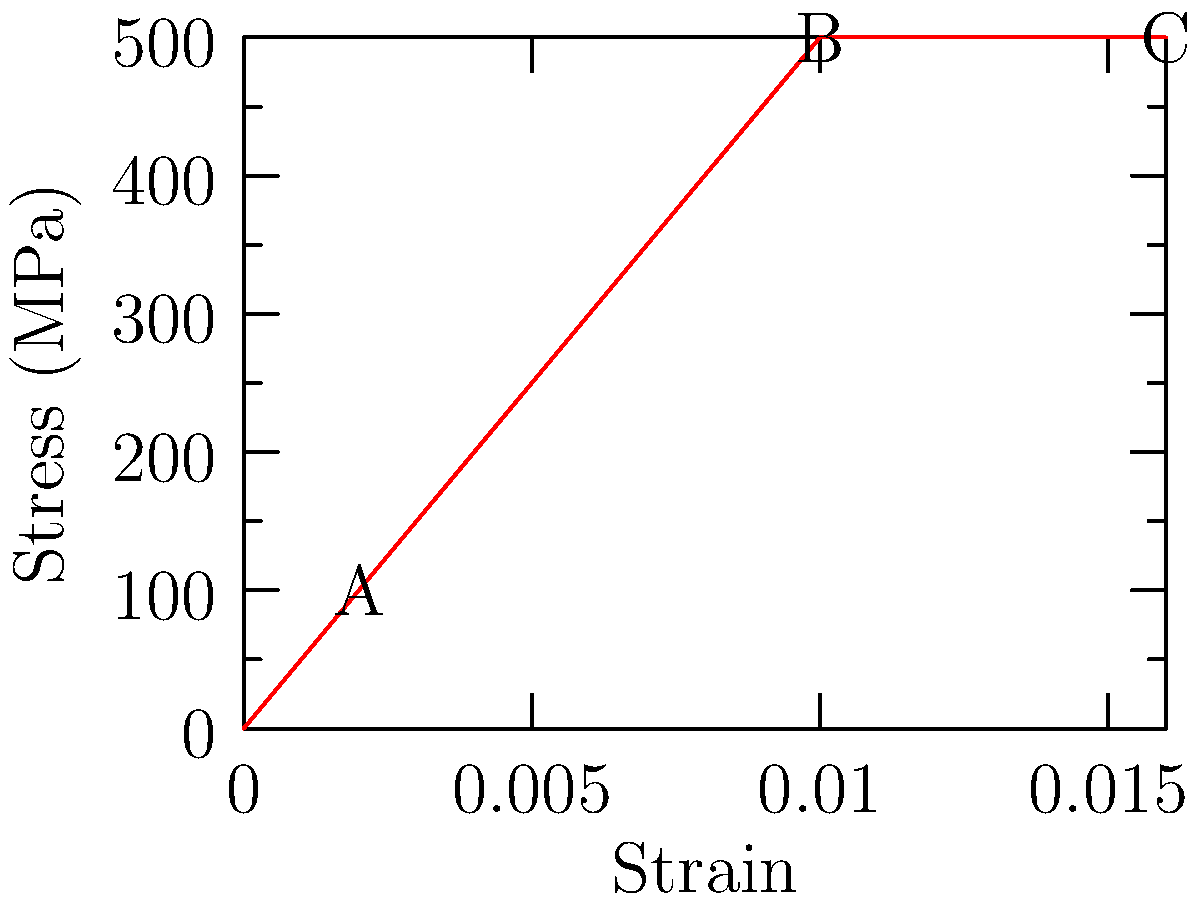In a thrilling action sequence from Nagarjuna's blockbuster movie "Mass," a high-tension cable is used for a daring stunt. The stress-strain curve for the cable material is shown above. If the cable has a cross-sectional area of 100 mm², determine the maximum force it can withstand before permanent deformation occurs. Let's approach this step-by-step, imagining we're designing the perfect stunt for our hero Nagarjuna:

1) First, we need to identify the yield point on the stress-strain curve. This is the point where the material transitions from elastic to plastic deformation. In our graph, this occurs at point B.

2) The stress at point B is 500 MPa. This is the maximum stress the material can withstand before permanent deformation occurs.

3) Recall the formula for stress: $\sigma = \frac{F}{A}$
   Where $\sigma$ is stress, $F$ is force, and $A$ is area.

4) We know $\sigma = 500$ MPa $= 500 \times 10^6$ Pa, and $A = 100$ mm² $= 100 \times 10^{-6}$ m².

5) Rearranging the formula to solve for force: $F = \sigma \times A$

6) Plugging in our values:
   $F = (500 \times 10^6 \text{ Pa}) \times (100 \times 10^{-6} \text{ m}²)$
   $F = 50,000 \text{ N} = 50 \text{ kN}$

Therefore, the maximum force the cable can withstand before permanent deformation is 50 kN, ensuring a safe yet spectacular stunt for our action hero!
Answer: 50 kN 